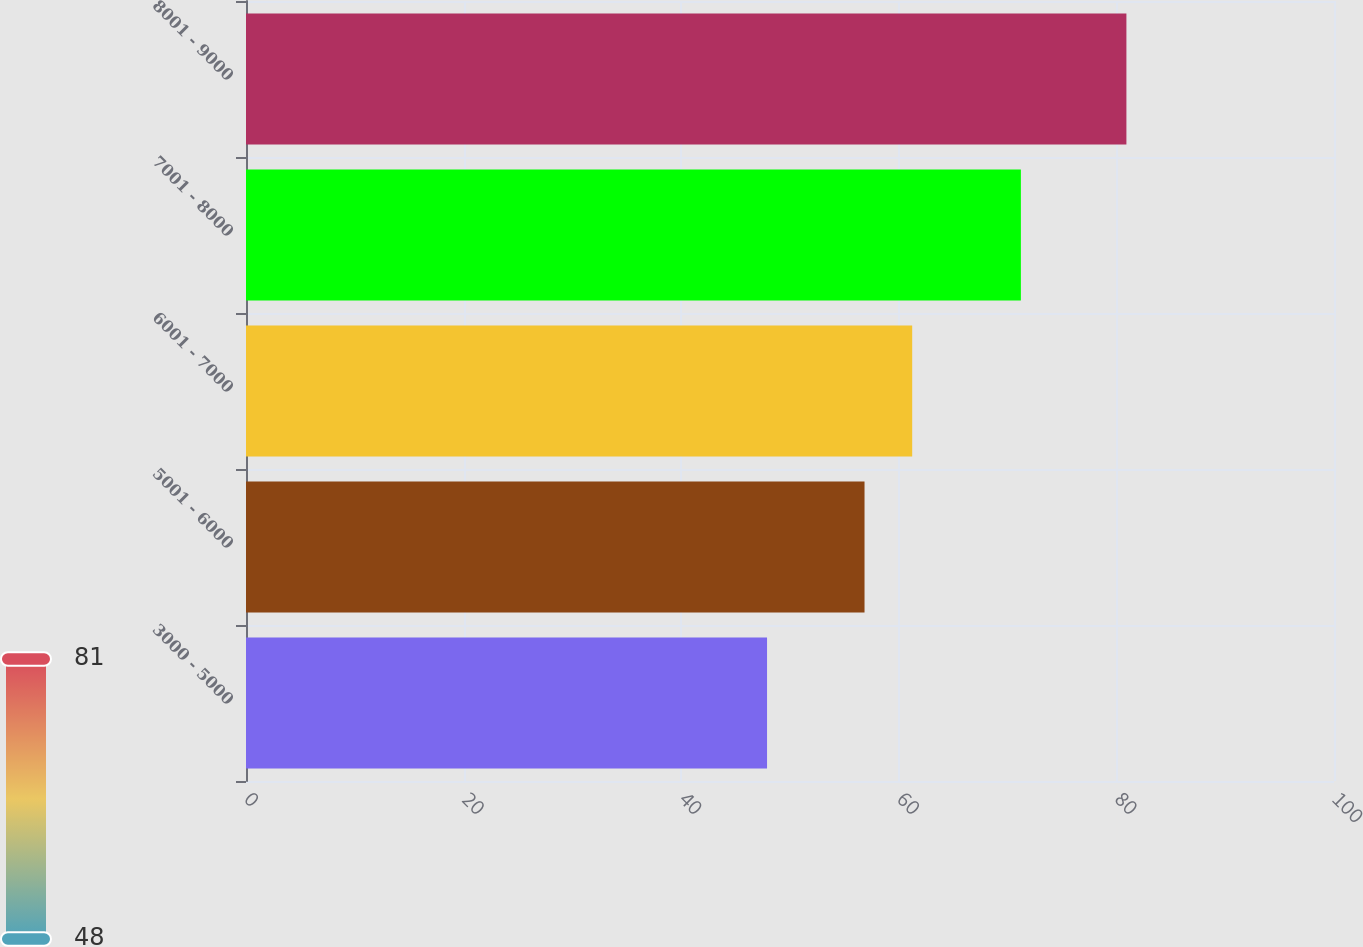Convert chart to OTSL. <chart><loc_0><loc_0><loc_500><loc_500><bar_chart><fcel>3000 - 5000<fcel>5001 - 6000<fcel>6001 - 7000<fcel>7001 - 8000<fcel>8001 - 9000<nl><fcel>47.89<fcel>56.85<fcel>61.23<fcel>71.22<fcel>80.92<nl></chart> 